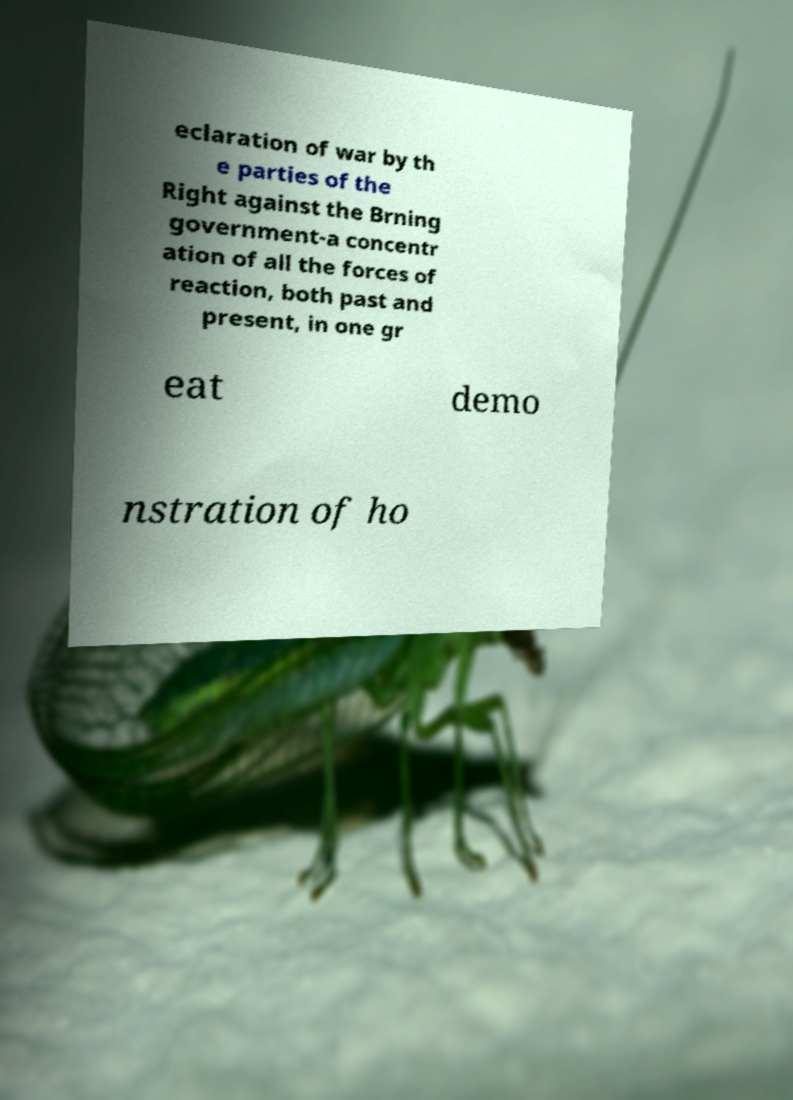Could you assist in decoding the text presented in this image and type it out clearly? eclaration of war by th e parties of the Right against the Brning government-a concentr ation of all the forces of reaction, both past and present, in one gr eat demo nstration of ho 